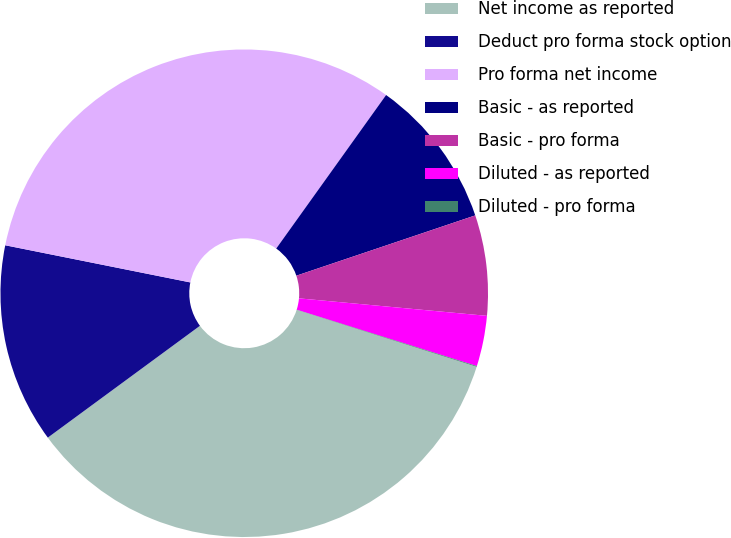<chart> <loc_0><loc_0><loc_500><loc_500><pie_chart><fcel>Net income as reported<fcel>Deduct pro forma stock option<fcel>Pro forma net income<fcel>Basic - as reported<fcel>Basic - pro forma<fcel>Diluted - as reported<fcel>Diluted - pro forma<nl><fcel>35.03%<fcel>13.24%<fcel>31.73%<fcel>9.94%<fcel>6.65%<fcel>3.35%<fcel>0.05%<nl></chart> 